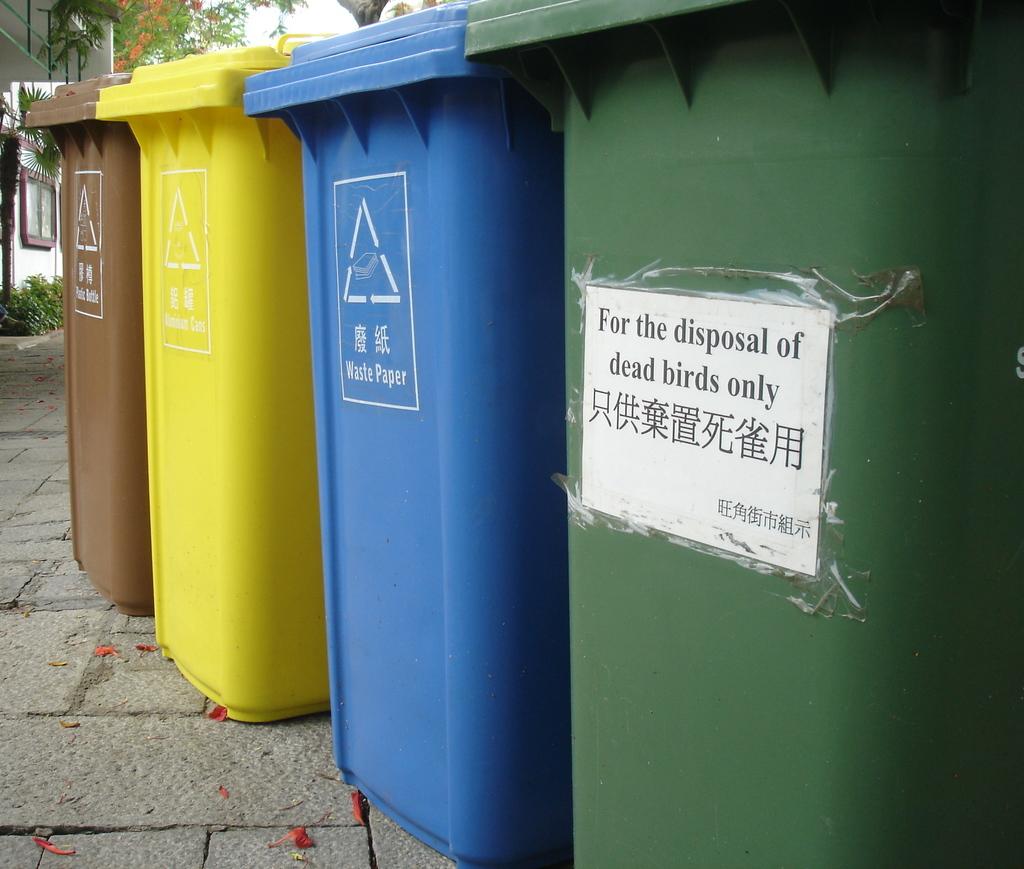What are you only suppose to put in the green dumpster?
Make the answer very short. Dead birds. 